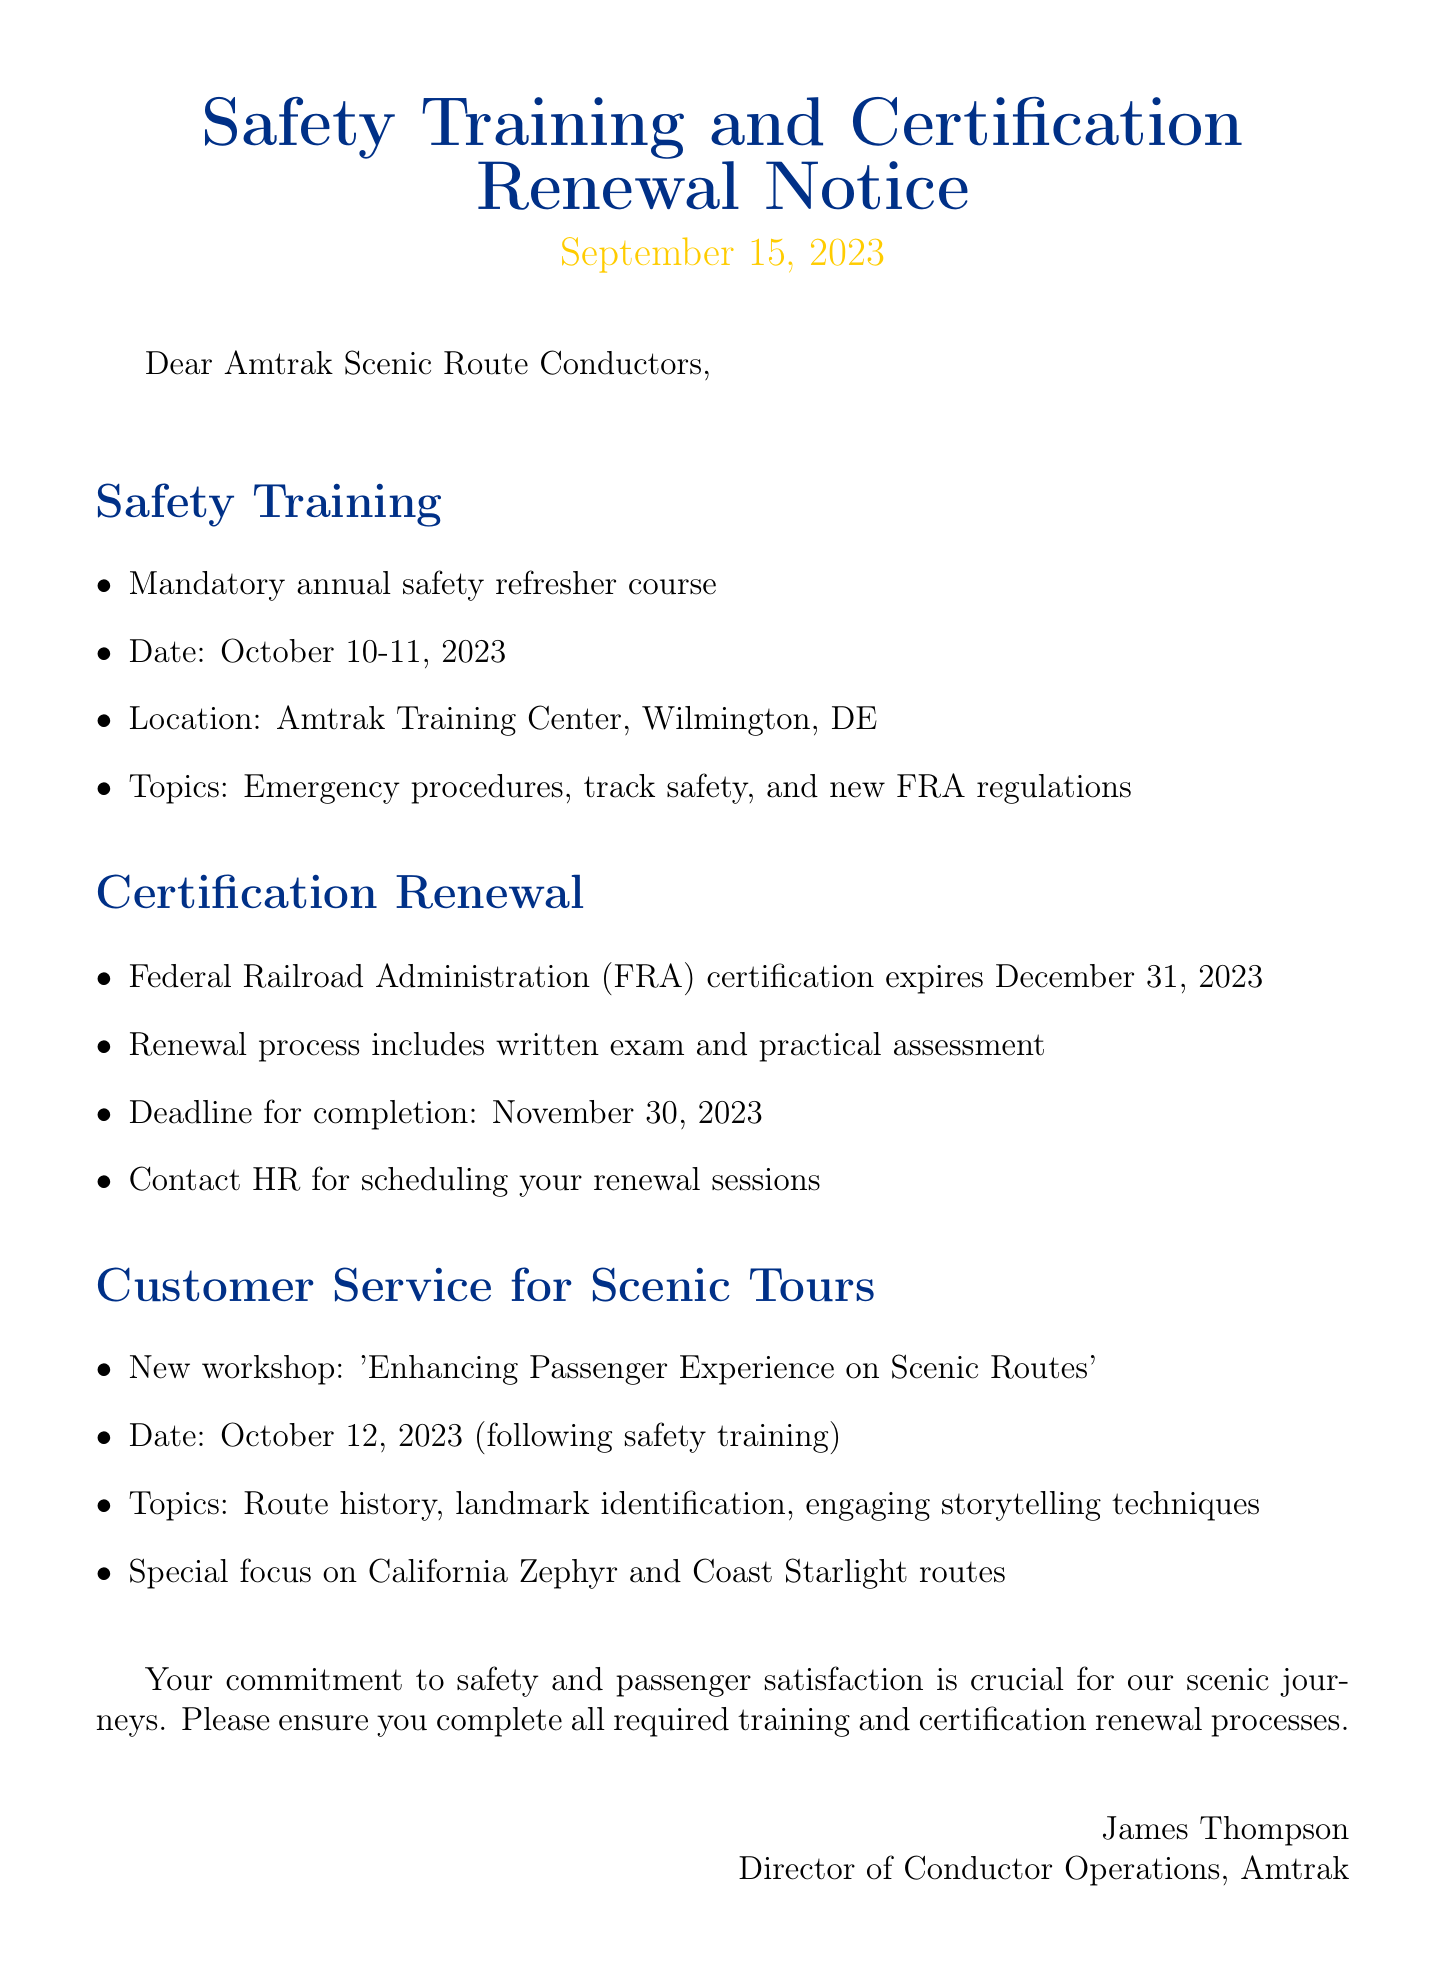What are the dates for the safety training? The safety training is scheduled for October 10-11, 2023.
Answer: October 10-11, 2023 What is the location for the safety training? The training will be held at the Amtrak Training Center in Wilmington, DE.
Answer: Amtrak Training Center, Wilmington, DE When does the FRA certification expire? The FRA certification expires on December 31, 2023.
Answer: December 31, 2023 What is the deadline for certification renewal completion? The deadline for completing the certification renewal process is November 30, 2023.
Answer: November 30, 2023 What is the title of the new workshop? The new workshop is titled 'Enhancing Passenger Experience on Scenic Routes'.
Answer: Enhancing Passenger Experience on Scenic Routes What special focus will the workshop have? The workshop will have a special focus on the California Zephyr and Coast Starlight routes.
Answer: California Zephyr and Coast Starlight routes Who is the sender of the notice? The sender of the notice is James Thompson.
Answer: James Thompson What topics will be covered in the safety training? The safety training will cover emergency procedures, track safety, and new FRA regulations.
Answer: Emergency procedures, track safety, and new FRA regulations What is the purpose of the customer service workshop? The workshop aims to improve passenger experience on scenic routes.
Answer: Improve passenger experience on scenic routes 